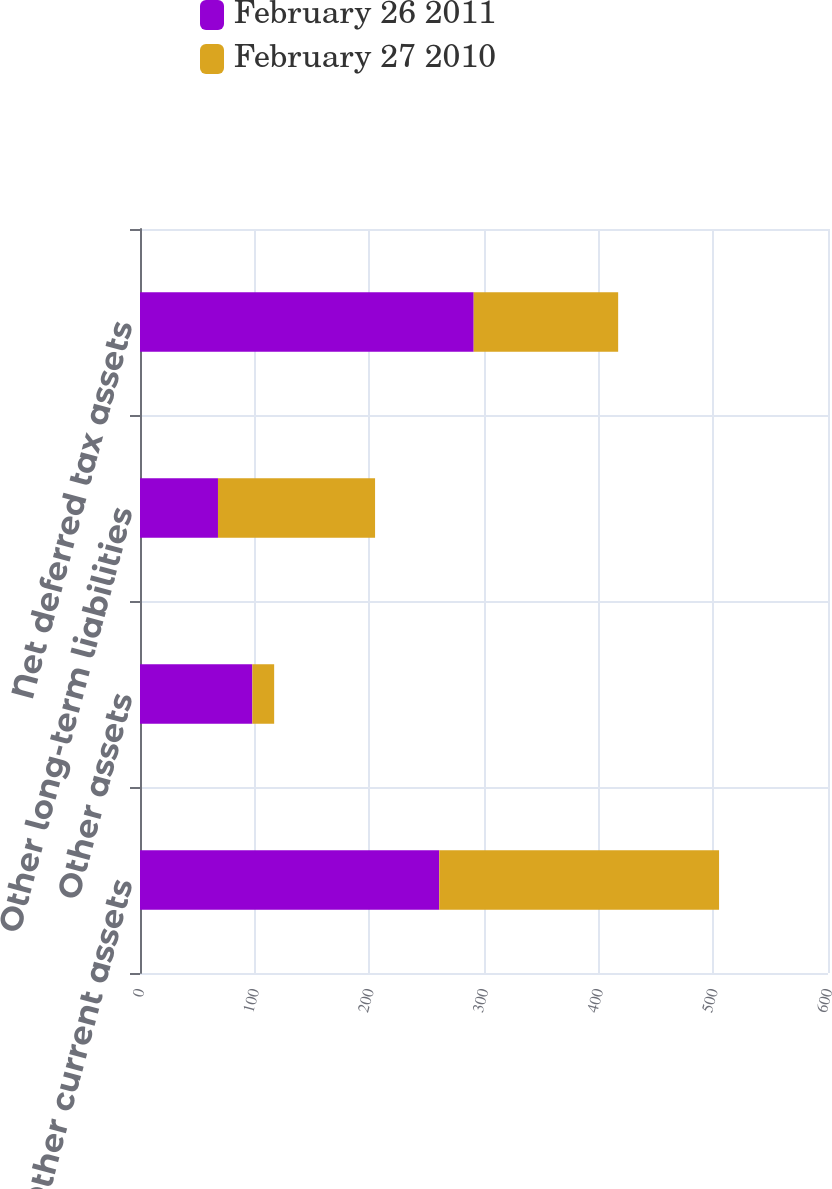<chart> <loc_0><loc_0><loc_500><loc_500><stacked_bar_chart><ecel><fcel>Other current assets<fcel>Other assets<fcel>Other long-term liabilities<fcel>Net deferred tax assets<nl><fcel>February 26 2011<fcel>261<fcel>98<fcel>68<fcel>291<nl><fcel>February 27 2010<fcel>244<fcel>19<fcel>137<fcel>126<nl></chart> 